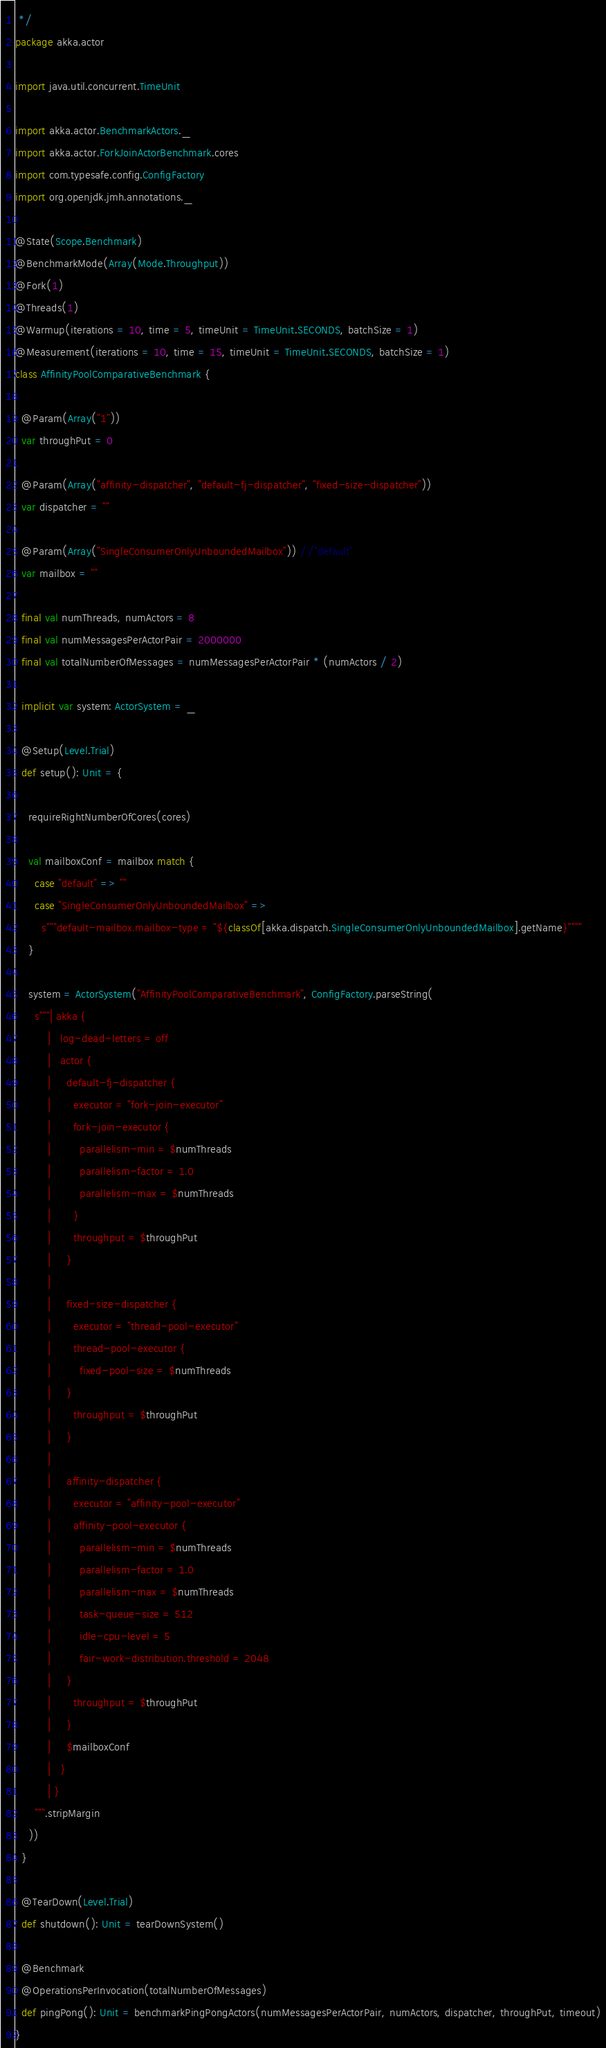<code> <loc_0><loc_0><loc_500><loc_500><_Scala_> */
package akka.actor

import java.util.concurrent.TimeUnit

import akka.actor.BenchmarkActors._
import akka.actor.ForkJoinActorBenchmark.cores
import com.typesafe.config.ConfigFactory
import org.openjdk.jmh.annotations._

@State(Scope.Benchmark)
@BenchmarkMode(Array(Mode.Throughput))
@Fork(1)
@Threads(1)
@Warmup(iterations = 10, time = 5, timeUnit = TimeUnit.SECONDS, batchSize = 1)
@Measurement(iterations = 10, time = 15, timeUnit = TimeUnit.SECONDS, batchSize = 1)
class AffinityPoolComparativeBenchmark {

  @Param(Array("1"))
  var throughPut = 0

  @Param(Array("affinity-dispatcher", "default-fj-dispatcher", "fixed-size-dispatcher"))
  var dispatcher = ""

  @Param(Array("SingleConsumerOnlyUnboundedMailbox")) //"default"
  var mailbox = ""

  final val numThreads, numActors = 8
  final val numMessagesPerActorPair = 2000000
  final val totalNumberOfMessages = numMessagesPerActorPair * (numActors / 2)

  implicit var system: ActorSystem = _

  @Setup(Level.Trial)
  def setup(): Unit = {

    requireRightNumberOfCores(cores)

    val mailboxConf = mailbox match {
      case "default" => ""
      case "SingleConsumerOnlyUnboundedMailbox" =>
        s"""default-mailbox.mailbox-type = "${classOf[akka.dispatch.SingleConsumerOnlyUnboundedMailbox].getName}""""
    }

    system = ActorSystem("AffinityPoolComparativeBenchmark", ConfigFactory.parseString(
      s"""| akka {
          |   log-dead-letters = off
          |   actor {
          |     default-fj-dispatcher {
          |       executor = "fork-join-executor"
          |       fork-join-executor {
          |         parallelism-min = $numThreads
          |         parallelism-factor = 1.0
          |         parallelism-max = $numThreads
          |       }
          |       throughput = $throughPut
          |     }
          |
          |     fixed-size-dispatcher {
          |       executor = "thread-pool-executor"
          |       thread-pool-executor {
          |         fixed-pool-size = $numThreads
          |     }
          |       throughput = $throughPut
          |     }
          |
          |     affinity-dispatcher {
          |       executor = "affinity-pool-executor"
          |       affinity-pool-executor {
          |         parallelism-min = $numThreads
          |         parallelism-factor = 1.0
          |         parallelism-max = $numThreads
          |         task-queue-size = 512
          |         idle-cpu-level = 5
          |         fair-work-distribution.threshold = 2048
          |     }
          |       throughput = $throughPut
          |     }
          |     $mailboxConf
          |   }
          | }
      """.stripMargin
    ))
  }

  @TearDown(Level.Trial)
  def shutdown(): Unit = tearDownSystem()

  @Benchmark
  @OperationsPerInvocation(totalNumberOfMessages)
  def pingPong(): Unit = benchmarkPingPongActors(numMessagesPerActorPair, numActors, dispatcher, throughPut, timeout)
}
</code> 